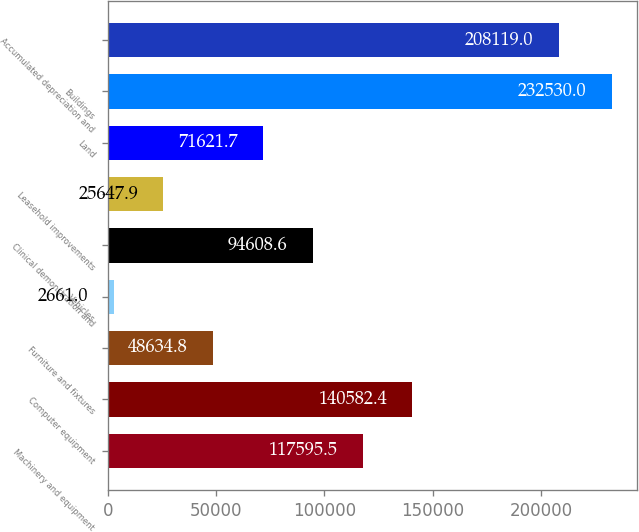Convert chart. <chart><loc_0><loc_0><loc_500><loc_500><bar_chart><fcel>Machinery and equipment<fcel>Computer equipment<fcel>Furniture and fixtures<fcel>Vehicles<fcel>Clinical demonstration and<fcel>Leasehold improvements<fcel>Land<fcel>Buildings<fcel>Accumulated depreciation and<nl><fcel>117596<fcel>140582<fcel>48634.8<fcel>2661<fcel>94608.6<fcel>25647.9<fcel>71621.7<fcel>232530<fcel>208119<nl></chart> 